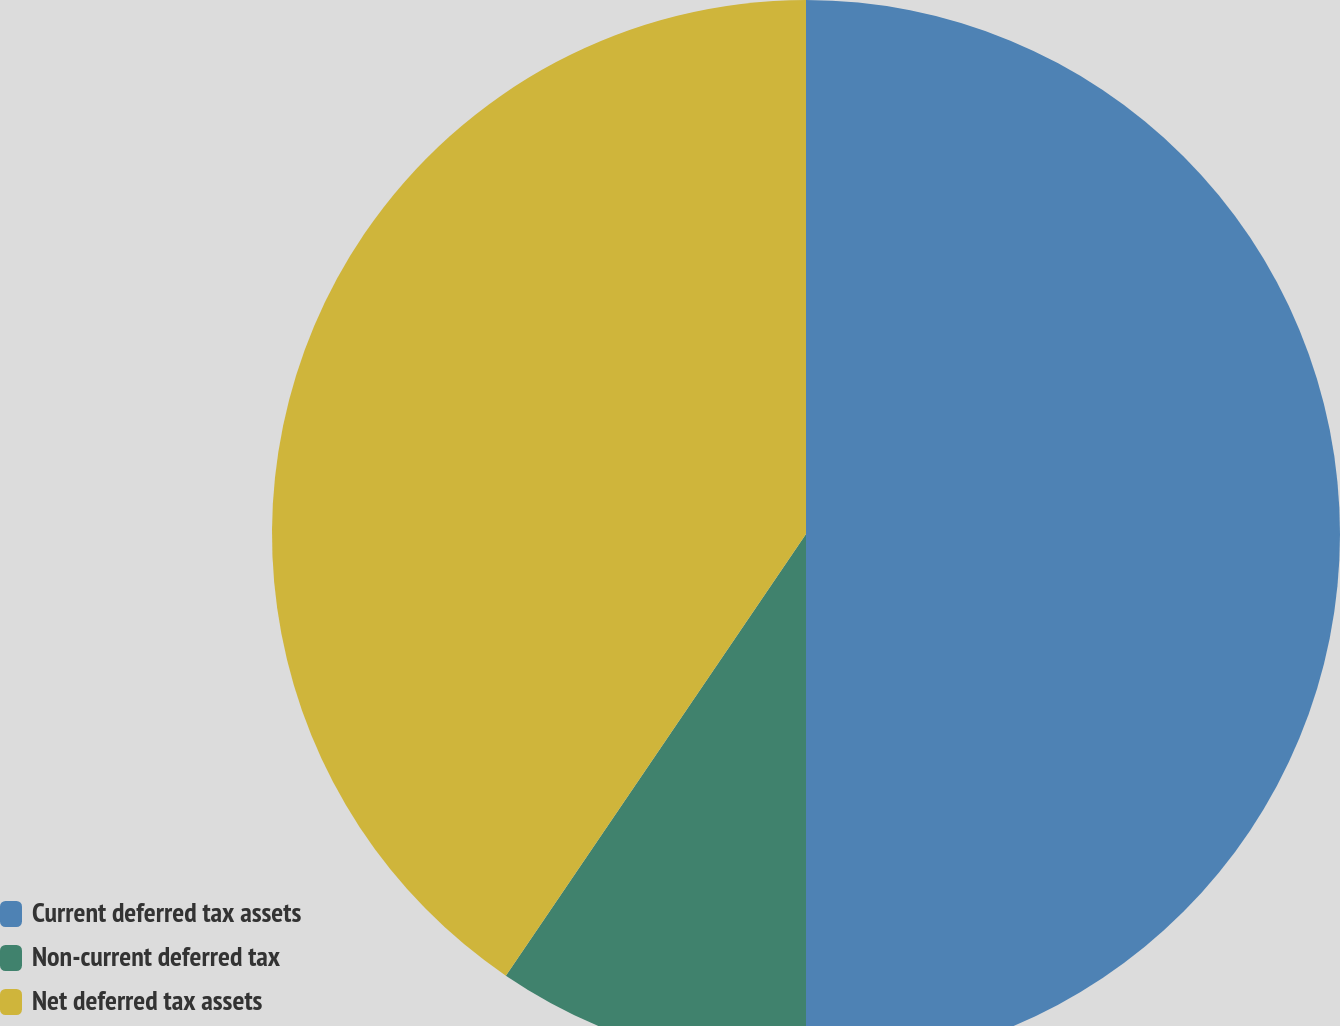Convert chart. <chart><loc_0><loc_0><loc_500><loc_500><pie_chart><fcel>Current deferred tax assets<fcel>Non-current deferred tax<fcel>Net deferred tax assets<nl><fcel>50.0%<fcel>9.5%<fcel>40.5%<nl></chart> 